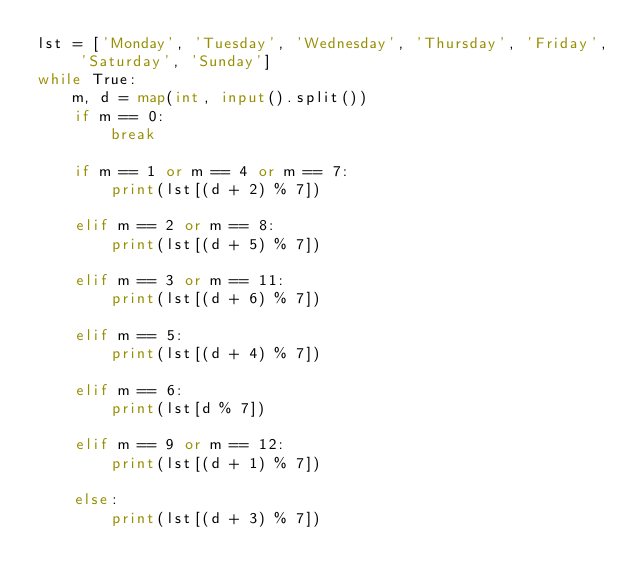<code> <loc_0><loc_0><loc_500><loc_500><_Python_>lst = ['Monday', 'Tuesday', 'Wednesday', 'Thursday', 'Friday', 'Saturday', 'Sunday']
while True:
    m, d = map(int, input().split())
    if m == 0:
        break
    
    if m == 1 or m == 4 or m == 7:
        print(lst[(d + 2) % 7])

    elif m == 2 or m == 8:
        print(lst[(d + 5) % 7])

    elif m == 3 or m == 11:
        print(lst[(d + 6) % 7])

    elif m == 5:
        print(lst[(d + 4) % 7])

    elif m == 6:
        print(lst[d % 7])

    elif m == 9 or m == 12:
        print(lst[(d + 1) % 7])

    else:
        print(lst[(d + 3) % 7])
</code> 